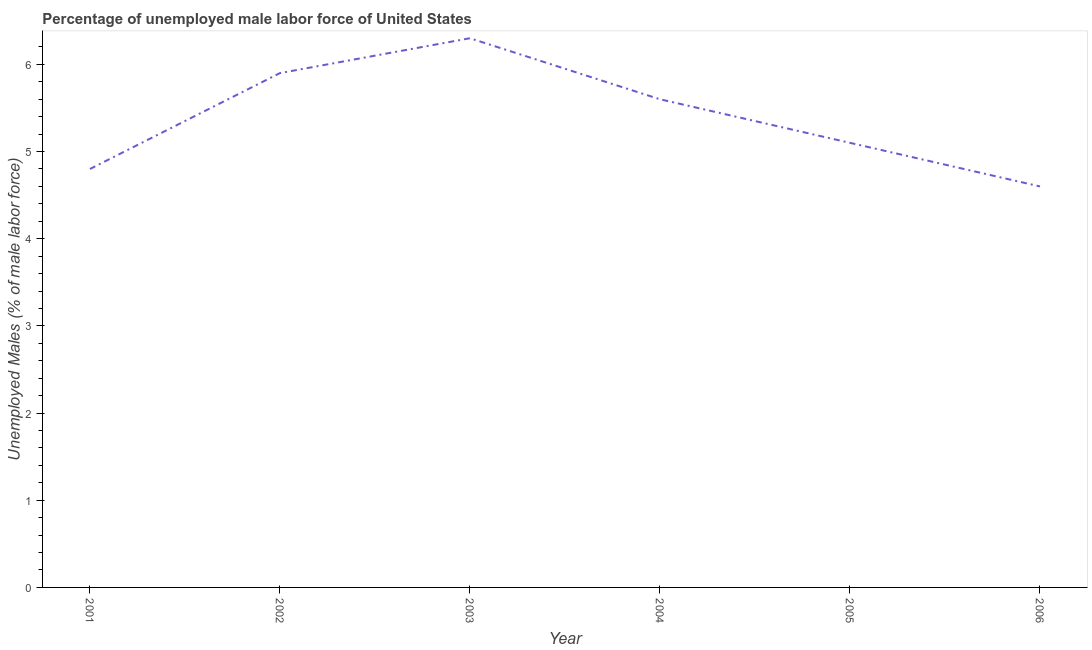What is the total unemployed male labour force in 2005?
Give a very brief answer. 5.1. Across all years, what is the maximum total unemployed male labour force?
Offer a terse response. 6.3. Across all years, what is the minimum total unemployed male labour force?
Keep it short and to the point. 4.6. What is the sum of the total unemployed male labour force?
Provide a short and direct response. 32.3. What is the difference between the total unemployed male labour force in 2002 and 2005?
Offer a terse response. 0.8. What is the average total unemployed male labour force per year?
Offer a very short reply. 5.38. What is the median total unemployed male labour force?
Make the answer very short. 5.35. What is the ratio of the total unemployed male labour force in 2004 to that in 2005?
Ensure brevity in your answer.  1.1. Is the total unemployed male labour force in 2005 less than that in 2006?
Ensure brevity in your answer.  No. What is the difference between the highest and the second highest total unemployed male labour force?
Provide a short and direct response. 0.4. What is the difference between the highest and the lowest total unemployed male labour force?
Give a very brief answer. 1.7. Does the total unemployed male labour force monotonically increase over the years?
Give a very brief answer. No. Does the graph contain grids?
Your answer should be compact. No. What is the title of the graph?
Offer a very short reply. Percentage of unemployed male labor force of United States. What is the label or title of the X-axis?
Your answer should be compact. Year. What is the label or title of the Y-axis?
Keep it short and to the point. Unemployed Males (% of male labor force). What is the Unemployed Males (% of male labor force) of 2001?
Your answer should be very brief. 4.8. What is the Unemployed Males (% of male labor force) in 2002?
Provide a succinct answer. 5.9. What is the Unemployed Males (% of male labor force) in 2003?
Your answer should be very brief. 6.3. What is the Unemployed Males (% of male labor force) in 2004?
Ensure brevity in your answer.  5.6. What is the Unemployed Males (% of male labor force) of 2005?
Give a very brief answer. 5.1. What is the Unemployed Males (% of male labor force) of 2006?
Your answer should be compact. 4.6. What is the difference between the Unemployed Males (% of male labor force) in 2002 and 2004?
Offer a terse response. 0.3. What is the difference between the Unemployed Males (% of male labor force) in 2002 and 2006?
Offer a very short reply. 1.3. What is the difference between the Unemployed Males (% of male labor force) in 2003 and 2005?
Give a very brief answer. 1.2. What is the difference between the Unemployed Males (% of male labor force) in 2003 and 2006?
Keep it short and to the point. 1.7. What is the ratio of the Unemployed Males (% of male labor force) in 2001 to that in 2002?
Keep it short and to the point. 0.81. What is the ratio of the Unemployed Males (% of male labor force) in 2001 to that in 2003?
Your response must be concise. 0.76. What is the ratio of the Unemployed Males (% of male labor force) in 2001 to that in 2004?
Make the answer very short. 0.86. What is the ratio of the Unemployed Males (% of male labor force) in 2001 to that in 2005?
Provide a succinct answer. 0.94. What is the ratio of the Unemployed Males (% of male labor force) in 2001 to that in 2006?
Provide a short and direct response. 1.04. What is the ratio of the Unemployed Males (% of male labor force) in 2002 to that in 2003?
Keep it short and to the point. 0.94. What is the ratio of the Unemployed Males (% of male labor force) in 2002 to that in 2004?
Offer a very short reply. 1.05. What is the ratio of the Unemployed Males (% of male labor force) in 2002 to that in 2005?
Provide a succinct answer. 1.16. What is the ratio of the Unemployed Males (% of male labor force) in 2002 to that in 2006?
Offer a terse response. 1.28. What is the ratio of the Unemployed Males (% of male labor force) in 2003 to that in 2004?
Offer a terse response. 1.12. What is the ratio of the Unemployed Males (% of male labor force) in 2003 to that in 2005?
Offer a terse response. 1.24. What is the ratio of the Unemployed Males (% of male labor force) in 2003 to that in 2006?
Keep it short and to the point. 1.37. What is the ratio of the Unemployed Males (% of male labor force) in 2004 to that in 2005?
Provide a succinct answer. 1.1. What is the ratio of the Unemployed Males (% of male labor force) in 2004 to that in 2006?
Ensure brevity in your answer.  1.22. What is the ratio of the Unemployed Males (% of male labor force) in 2005 to that in 2006?
Ensure brevity in your answer.  1.11. 